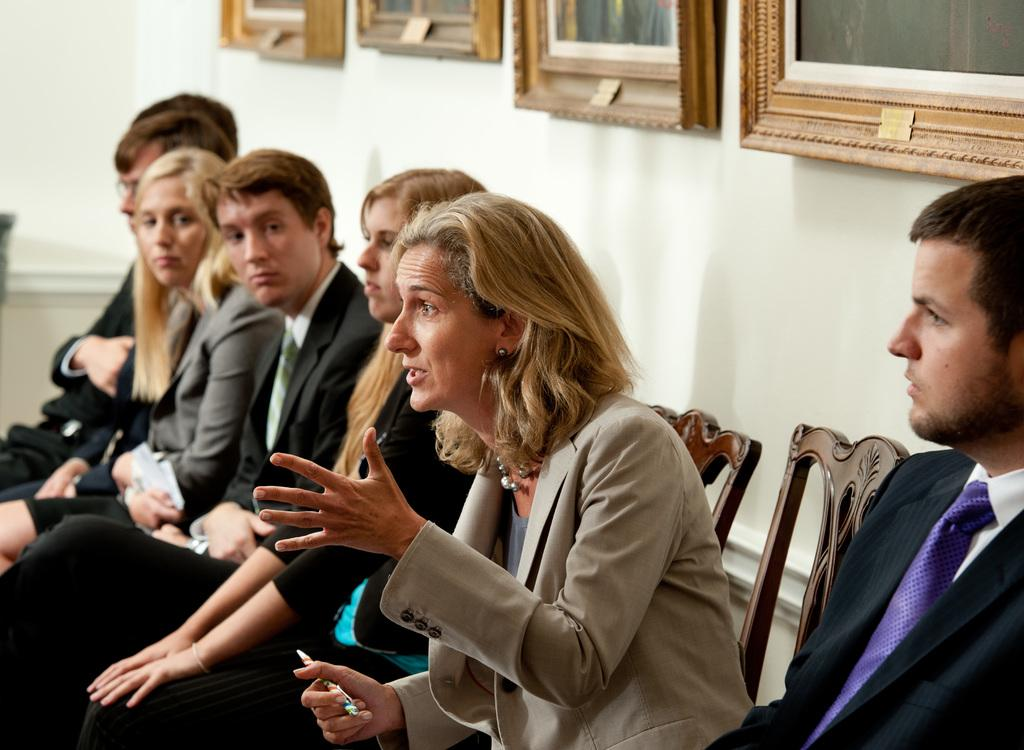What is happening in the image involving a group of people? There is a group of people sitting on chairs in the image. What is the woman holding in the image? The woman is holding a pen in the image. What is the woman doing in the image? The woman is explaining something in the image. What can be seen in the background of the image? There is a wall with photo frames in the background of the image. Can you see any giants walking along the coast in the image? There are no giants or coast visible in the image; it features a group of people sitting on chairs, a woman holding a pen and explaining something, and a wall with photo frames in the background. 